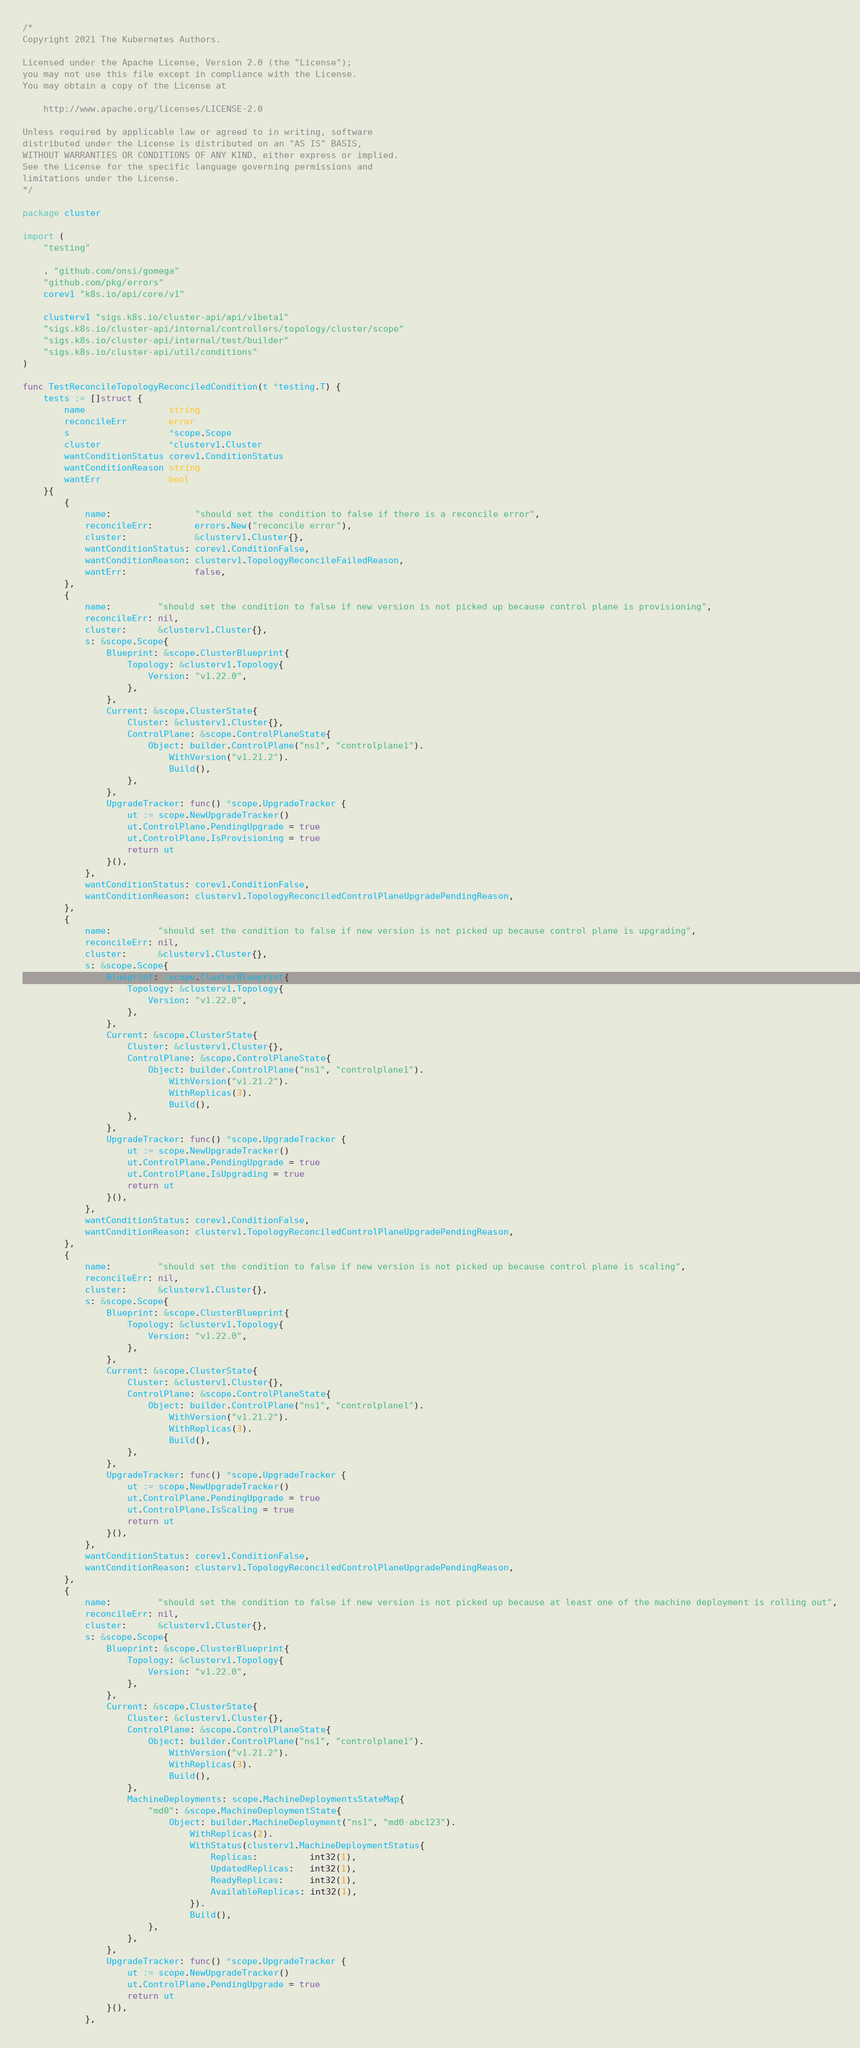Convert code to text. <code><loc_0><loc_0><loc_500><loc_500><_Go_>/*
Copyright 2021 The Kubernetes Authors.

Licensed under the Apache License, Version 2.0 (the "License");
you may not use this file except in compliance with the License.
You may obtain a copy of the License at

    http://www.apache.org/licenses/LICENSE-2.0

Unless required by applicable law or agreed to in writing, software
distributed under the License is distributed on an "AS IS" BASIS,
WITHOUT WARRANTIES OR CONDITIONS OF ANY KIND, either express or implied.
See the License for the specific language governing permissions and
limitations under the License.
*/

package cluster

import (
	"testing"

	. "github.com/onsi/gomega"
	"github.com/pkg/errors"
	corev1 "k8s.io/api/core/v1"

	clusterv1 "sigs.k8s.io/cluster-api/api/v1beta1"
	"sigs.k8s.io/cluster-api/internal/controllers/topology/cluster/scope"
	"sigs.k8s.io/cluster-api/internal/test/builder"
	"sigs.k8s.io/cluster-api/util/conditions"
)

func TestReconcileTopologyReconciledCondition(t *testing.T) {
	tests := []struct {
		name                string
		reconcileErr        error
		s                   *scope.Scope
		cluster             *clusterv1.Cluster
		wantConditionStatus corev1.ConditionStatus
		wantConditionReason string
		wantErr             bool
	}{
		{
			name:                "should set the condition to false if there is a reconcile error",
			reconcileErr:        errors.New("reconcile error"),
			cluster:             &clusterv1.Cluster{},
			wantConditionStatus: corev1.ConditionFalse,
			wantConditionReason: clusterv1.TopologyReconcileFailedReason,
			wantErr:             false,
		},
		{
			name:         "should set the condition to false if new version is not picked up because control plane is provisioning",
			reconcileErr: nil,
			cluster:      &clusterv1.Cluster{},
			s: &scope.Scope{
				Blueprint: &scope.ClusterBlueprint{
					Topology: &clusterv1.Topology{
						Version: "v1.22.0",
					},
				},
				Current: &scope.ClusterState{
					Cluster: &clusterv1.Cluster{},
					ControlPlane: &scope.ControlPlaneState{
						Object: builder.ControlPlane("ns1", "controlplane1").
							WithVersion("v1.21.2").
							Build(),
					},
				},
				UpgradeTracker: func() *scope.UpgradeTracker {
					ut := scope.NewUpgradeTracker()
					ut.ControlPlane.PendingUpgrade = true
					ut.ControlPlane.IsProvisioning = true
					return ut
				}(),
			},
			wantConditionStatus: corev1.ConditionFalse,
			wantConditionReason: clusterv1.TopologyReconciledControlPlaneUpgradePendingReason,
		},
		{
			name:         "should set the condition to false if new version is not picked up because control plane is upgrading",
			reconcileErr: nil,
			cluster:      &clusterv1.Cluster{},
			s: &scope.Scope{
				Blueprint: &scope.ClusterBlueprint{
					Topology: &clusterv1.Topology{
						Version: "v1.22.0",
					},
				},
				Current: &scope.ClusterState{
					Cluster: &clusterv1.Cluster{},
					ControlPlane: &scope.ControlPlaneState{
						Object: builder.ControlPlane("ns1", "controlplane1").
							WithVersion("v1.21.2").
							WithReplicas(3).
							Build(),
					},
				},
				UpgradeTracker: func() *scope.UpgradeTracker {
					ut := scope.NewUpgradeTracker()
					ut.ControlPlane.PendingUpgrade = true
					ut.ControlPlane.IsUpgrading = true
					return ut
				}(),
			},
			wantConditionStatus: corev1.ConditionFalse,
			wantConditionReason: clusterv1.TopologyReconciledControlPlaneUpgradePendingReason,
		},
		{
			name:         "should set the condition to false if new version is not picked up because control plane is scaling",
			reconcileErr: nil,
			cluster:      &clusterv1.Cluster{},
			s: &scope.Scope{
				Blueprint: &scope.ClusterBlueprint{
					Topology: &clusterv1.Topology{
						Version: "v1.22.0",
					},
				},
				Current: &scope.ClusterState{
					Cluster: &clusterv1.Cluster{},
					ControlPlane: &scope.ControlPlaneState{
						Object: builder.ControlPlane("ns1", "controlplane1").
							WithVersion("v1.21.2").
							WithReplicas(3).
							Build(),
					},
				},
				UpgradeTracker: func() *scope.UpgradeTracker {
					ut := scope.NewUpgradeTracker()
					ut.ControlPlane.PendingUpgrade = true
					ut.ControlPlane.IsScaling = true
					return ut
				}(),
			},
			wantConditionStatus: corev1.ConditionFalse,
			wantConditionReason: clusterv1.TopologyReconciledControlPlaneUpgradePendingReason,
		},
		{
			name:         "should set the condition to false if new version is not picked up because at least one of the machine deployment is rolling out",
			reconcileErr: nil,
			cluster:      &clusterv1.Cluster{},
			s: &scope.Scope{
				Blueprint: &scope.ClusterBlueprint{
					Topology: &clusterv1.Topology{
						Version: "v1.22.0",
					},
				},
				Current: &scope.ClusterState{
					Cluster: &clusterv1.Cluster{},
					ControlPlane: &scope.ControlPlaneState{
						Object: builder.ControlPlane("ns1", "controlplane1").
							WithVersion("v1.21.2").
							WithReplicas(3).
							Build(),
					},
					MachineDeployments: scope.MachineDeploymentsStateMap{
						"md0": &scope.MachineDeploymentState{
							Object: builder.MachineDeployment("ns1", "md0-abc123").
								WithReplicas(2).
								WithStatus(clusterv1.MachineDeploymentStatus{
									Replicas:          int32(1),
									UpdatedReplicas:   int32(1),
									ReadyReplicas:     int32(1),
									AvailableReplicas: int32(1),
								}).
								Build(),
						},
					},
				},
				UpgradeTracker: func() *scope.UpgradeTracker {
					ut := scope.NewUpgradeTracker()
					ut.ControlPlane.PendingUpgrade = true
					return ut
				}(),
			},</code> 